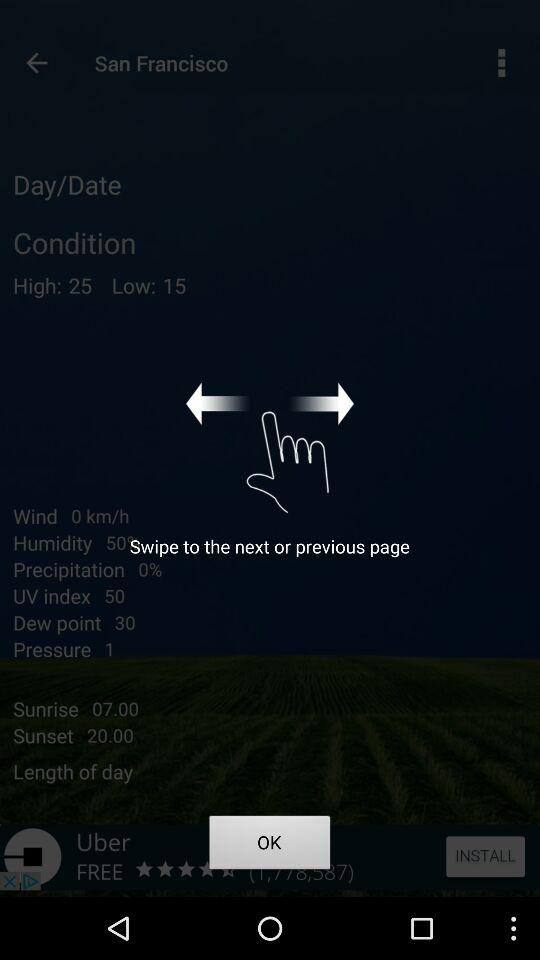What is the humidity percentage? The humidity is 50%. 